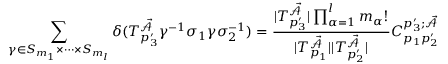<formula> <loc_0><loc_0><loc_500><loc_500>\sum _ { \gamma \in S _ { m _ { 1 } } \times \dots \times S _ { m _ { l } } } \delta ( T _ { p _ { 3 } ^ { \prime } } ^ { \mathcal { \vec { A } } } \gamma ^ { - 1 } \sigma _ { 1 } \gamma \sigma _ { 2 } ^ { - 1 } ) = \frac { | T _ { p _ { 3 } ^ { \prime } } ^ { \mathcal { \vec { A } } } | \prod _ { \alpha = 1 } ^ { l } m _ { \alpha } ! } { | T _ { p _ { 1 } } ^ { \mathcal { \vec { A } } } | | T _ { p _ { 2 } ^ { \prime } } ^ { \mathcal { \vec { A } } } | } C _ { p _ { 1 } p _ { 2 } ^ { \prime } } ^ { p _ { 3 } ^ { \prime } ; \mathcal { \vec { A } } }</formula> 